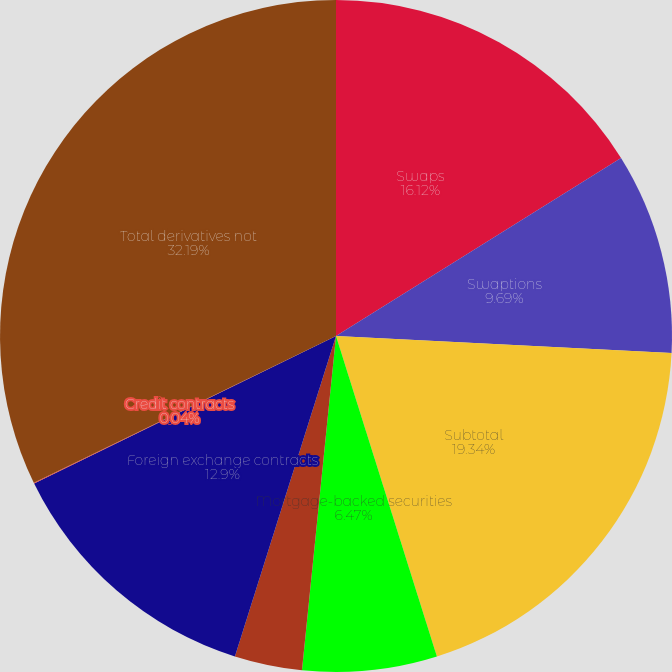<chart> <loc_0><loc_0><loc_500><loc_500><pie_chart><fcel>Swaps<fcel>Swaptions<fcel>Subtotal<fcel>Mortgage-backed securities<fcel>Commercial mortgage loan<fcel>Foreign exchange contracts<fcel>Credit contracts<fcel>Total derivatives not<nl><fcel>16.12%<fcel>9.69%<fcel>19.34%<fcel>6.47%<fcel>3.25%<fcel>12.9%<fcel>0.04%<fcel>32.2%<nl></chart> 